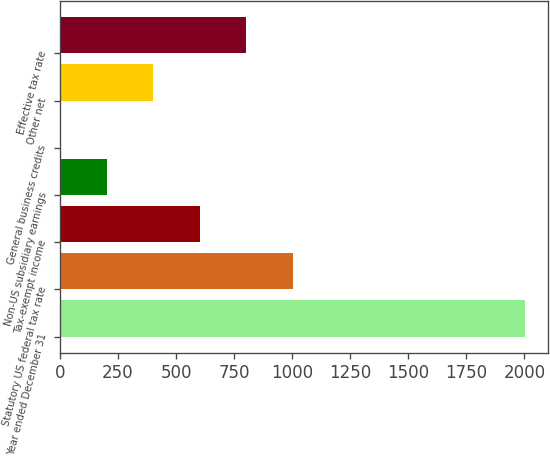Convert chart. <chart><loc_0><loc_0><loc_500><loc_500><bar_chart><fcel>Year ended December 31<fcel>Statutory US federal tax rate<fcel>Tax-exempt income<fcel>Non-US subsidiary earnings<fcel>General business credits<fcel>Other net<fcel>Effective tax rate<nl><fcel>2003<fcel>1001.95<fcel>601.53<fcel>201.11<fcel>0.9<fcel>401.32<fcel>801.74<nl></chart> 